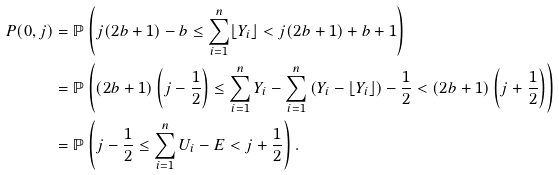Convert formula to latex. <formula><loc_0><loc_0><loc_500><loc_500>P ( 0 , j ) & = \mathbb { P } \left ( j ( 2 b + 1 ) - b \leq \sum _ { i = 1 } ^ { n } \lfloor Y _ { i } \rfloor < j ( 2 b + 1 ) + b + 1 \right ) \\ & = \mathbb { P } \left ( ( 2 b + 1 ) \left ( j - \frac { 1 } { 2 } \right ) \leq \sum _ { i = 1 } ^ { n } Y _ { i } - \sum _ { i = 1 } ^ { n } \left ( Y _ { i } - \lfloor Y _ { i } \rfloor \right ) - \frac { 1 } { 2 } < ( 2 b + 1 ) \left ( j + \frac { 1 } { 2 } \right ) \right ) \\ & = \mathbb { P } \left ( j - \frac { 1 } { 2 } \leq \sum _ { i = 1 } ^ { n } U _ { i } - E < j + \frac { 1 } { 2 } \right ) .</formula> 